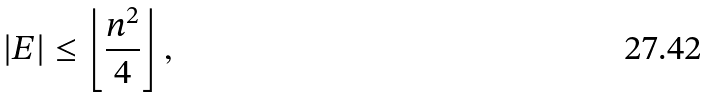<formula> <loc_0><loc_0><loc_500><loc_500>| E | \leq \left \lfloor \frac { n ^ { 2 } } { 4 } \right \rfloor ,</formula> 